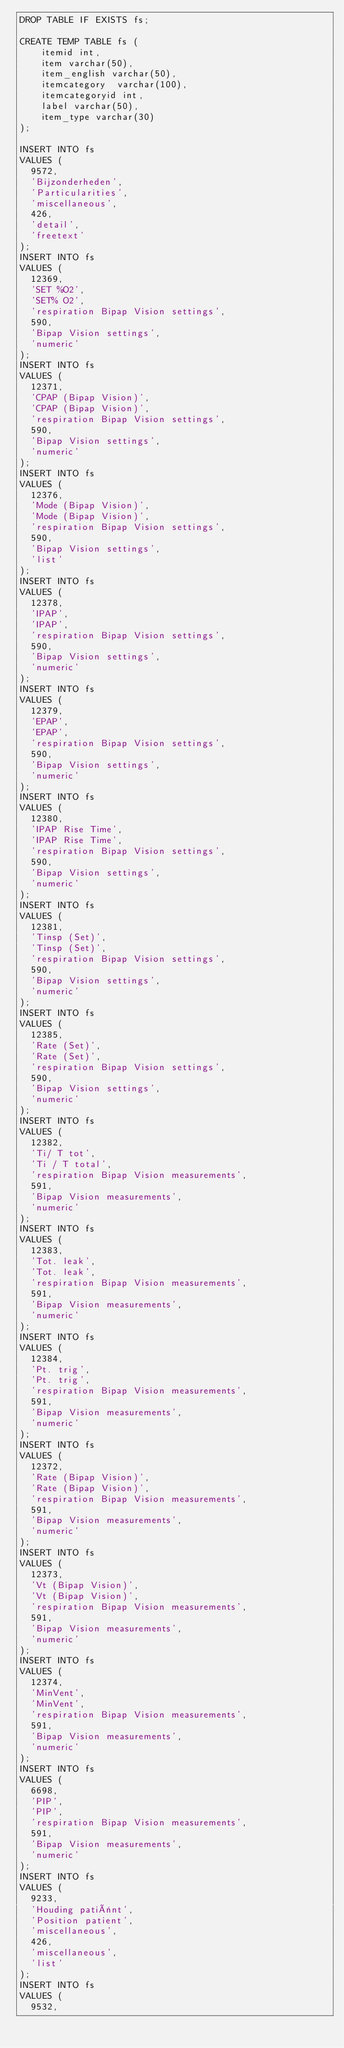<code> <loc_0><loc_0><loc_500><loc_500><_SQL_>DROP TABLE IF EXISTS fs;

CREATE TEMP TABLE fs (
    itemid int, 
    item varchar(50),
    item_english varchar(50),
    itemcategory  varchar(100),
    itemcategoryid int,
    label varchar(50),
    item_type varchar(30)
); 

INSERT INTO fs
VALUES (
  9572, 
  'Bijzonderheden', 
  'Particularities', 
  'miscellaneous', 
  426, 
  'detail', 
  'freetext'
);
INSERT INTO fs
VALUES (
  12369, 
  'SET %O2', 
  'SET% O2', 
  'respiration Bipap Vision settings', 
  590, 
  'Bipap Vision settings', 
  'numeric'
);
INSERT INTO fs
VALUES (
  12371, 
  'CPAP (Bipap Vision)', 
  'CPAP (Bipap Vision)', 
  'respiration Bipap Vision settings', 
  590, 
  'Bipap Vision settings', 
  'numeric'
);
INSERT INTO fs
VALUES (
  12376, 
  'Mode (Bipap Vision)', 
  'Mode (Bipap Vision)', 
  'respiration Bipap Vision settings', 
  590, 
  'Bipap Vision settings', 
  'list'
);
INSERT INTO fs
VALUES (
  12378, 
  'IPAP', 
  'IPAP', 
  'respiration Bipap Vision settings', 
  590, 
  'Bipap Vision settings', 
  'numeric'
);
INSERT INTO fs
VALUES (
  12379, 
  'EPAP', 
  'EPAP', 
  'respiration Bipap Vision settings', 
  590, 
  'Bipap Vision settings', 
  'numeric'
);
INSERT INTO fs
VALUES (
  12380, 
  'IPAP Rise Time', 
  'IPAP Rise Time', 
  'respiration Bipap Vision settings', 
  590, 
  'Bipap Vision settings', 
  'numeric'
);
INSERT INTO fs
VALUES (
  12381, 
  'Tinsp (Set)', 
  'Tinsp (Set)', 
  'respiration Bipap Vision settings', 
  590, 
  'Bipap Vision settings', 
  'numeric'
);
INSERT INTO fs
VALUES (
  12385, 
  'Rate (Set)', 
  'Rate (Set)', 
  'respiration Bipap Vision settings', 
  590, 
  'Bipap Vision settings', 
  'numeric'
);
INSERT INTO fs
VALUES (
  12382, 
  'Ti/ T tot', 
  'Ti / T total', 
  'respiration Bipap Vision measurements', 
  591, 
  'Bipap Vision measurements', 
  'numeric'
);
INSERT INTO fs
VALUES (
  12383, 
  'Tot. leak', 
  'Tot. leak', 
  'respiration Bipap Vision measurements', 
  591, 
  'Bipap Vision measurements', 
  'numeric'
);
INSERT INTO fs
VALUES (
  12384, 
  'Pt. trig', 
  'Pt. trig', 
  'respiration Bipap Vision measurements', 
  591, 
  'Bipap Vision measurements', 
  'numeric'
);
INSERT INTO fs
VALUES (
  12372, 
  'Rate (Bipap Vision)', 
  'Rate (Bipap Vision)', 
  'respiration Bipap Vision measurements', 
  591, 
  'Bipap Vision measurements', 
  'numeric'
);
INSERT INTO fs
VALUES (
  12373, 
  'Vt (Bipap Vision)', 
  'Vt (Bipap Vision)', 
  'respiration Bipap Vision measurements', 
  591, 
  'Bipap Vision measurements', 
  'numeric'
);
INSERT INTO fs
VALUES (
  12374, 
  'MinVent', 
  'MinVent', 
  'respiration Bipap Vision measurements', 
  591, 
  'Bipap Vision measurements', 
  'numeric'
);
INSERT INTO fs
VALUES (
  6698, 
  'PIP', 
  'PIP', 
  'respiration Bipap Vision measurements', 
  591, 
  'Bipap Vision measurements', 
  'numeric'
);
INSERT INTO fs
VALUES (
  9233, 
  'Houding patiënt', 
  'Position patient', 
  'miscellaneous', 
  426, 
  'miscellaneous', 
  'list'
);
INSERT INTO fs
VALUES (
  9532, </code> 